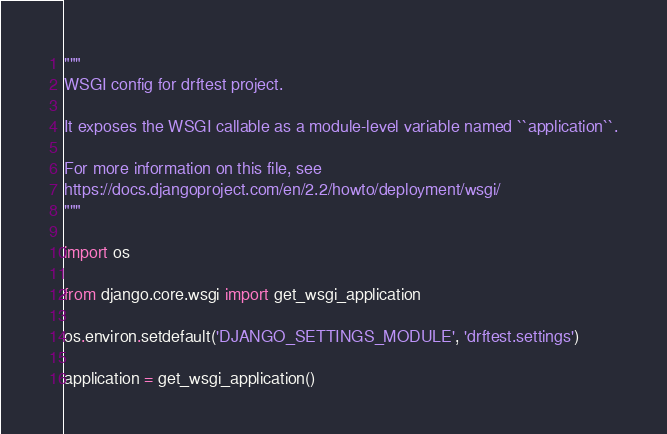Convert code to text. <code><loc_0><loc_0><loc_500><loc_500><_Python_>"""
WSGI config for drftest project.

It exposes the WSGI callable as a module-level variable named ``application``.

For more information on this file, see
https://docs.djangoproject.com/en/2.2/howto/deployment/wsgi/
"""

import os

from django.core.wsgi import get_wsgi_application

os.environ.setdefault('DJANGO_SETTINGS_MODULE', 'drftest.settings')

application = get_wsgi_application()
</code> 